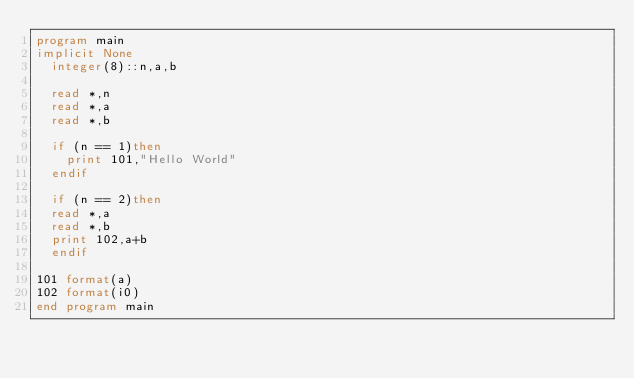Convert code to text. <code><loc_0><loc_0><loc_500><loc_500><_FORTRAN_>program main
implicit None
	integer(8)::n,a,b
	
	read *,n
	read *,a
	read *,b
	
	if (n == 1)then
		print 101,"Hello World"
	endif
	
	if (n == 2)then
	read *,a
	read *,b
	print 102,a+b
	endif
	
101 format(a)
102 format(i0)
end program main</code> 